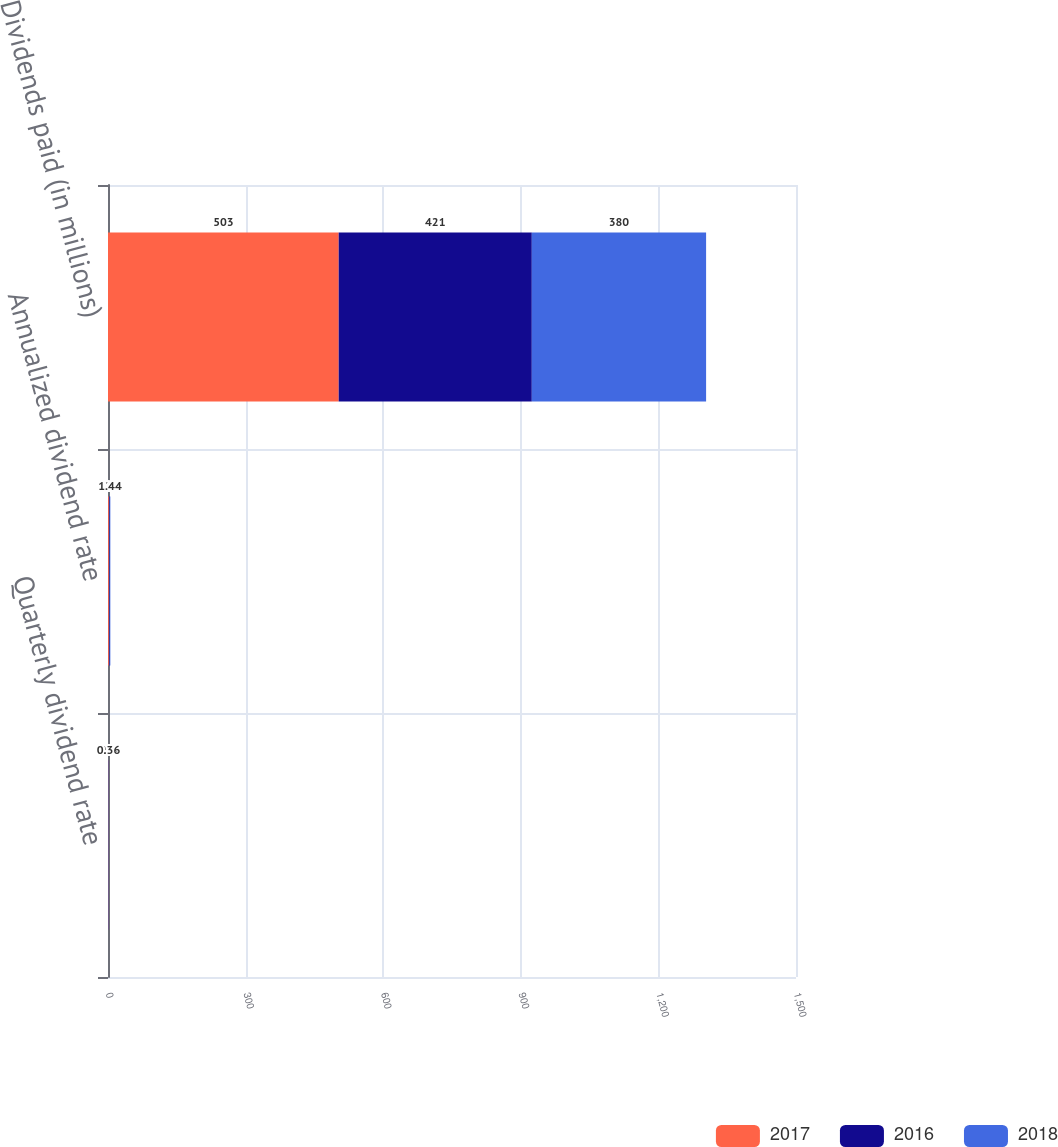<chart> <loc_0><loc_0><loc_500><loc_500><stacked_bar_chart><ecel><fcel>Quarterly dividend rate<fcel>Annualized dividend rate<fcel>Dividends paid (in millions)<nl><fcel>2017<fcel>0.5<fcel>2<fcel>503<nl><fcel>2016<fcel>0.41<fcel>1.64<fcel>421<nl><fcel>2018<fcel>0.36<fcel>1.44<fcel>380<nl></chart> 